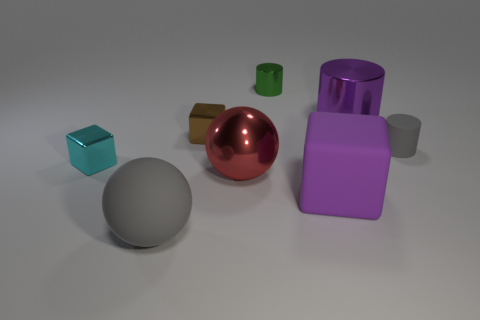Subtract all big cylinders. How many cylinders are left? 2 Subtract 1 cylinders. How many cylinders are left? 2 Subtract all purple blocks. How many blocks are left? 2 Add 2 red metallic cubes. How many objects exist? 10 Subtract all spheres. How many objects are left? 6 Subtract all gray cubes. Subtract all gray cylinders. How many cubes are left? 3 Subtract all gray metal cubes. Subtract all red metal things. How many objects are left? 7 Add 4 small green things. How many small green things are left? 5 Add 4 tiny matte cylinders. How many tiny matte cylinders exist? 5 Subtract 1 brown cubes. How many objects are left? 7 